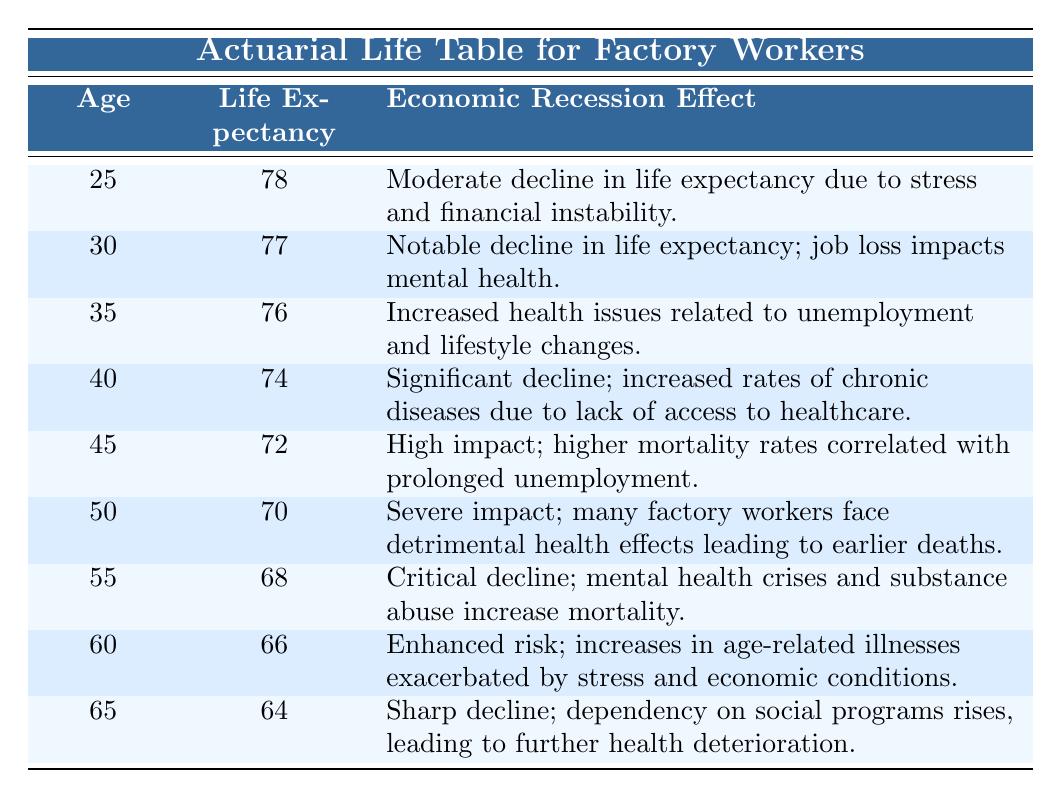What is the life expectancy of factory workers at age 50? The table indicates that the life expectancy of factory workers at age 50 is explicitly listed as 70 years.
Answer: 70 How does the economic recession affect life expectancy at age 40? The entry for age 40 states that there is a "significant decline; increased rates of chronic diseases due to lack of access to healthcare." This indicates that economic recession has a notable negative impact on health at this age.
Answer: Yes What is the difference in life expectancy between ages 35 and 60? The life expectancy for age 35 is 76 years, while for age 60, it is 66 years. Therefore, the difference in life expectancy is calculated as 76 - 66 = 10 years.
Answer: 10 Is there a critical decline in life expectancy for factory workers at age 55? The description for age 55 states “critical decline; mental health crises and substance abuse increase mortality,” which supports that there is indeed a critical decline at this age.
Answer: Yes What is the average life expectancy based on the provided age groups? To find the average, we first sum all the life expectancies: 78 + 77 + 76 + 74 + 72 + 70 + 68 + 66 + 64 = 585. Then, dividing by the number of age groups (9), we get 585 / 9 = 65.
Answer: 65 What is the overall trend in life expectancy from ages 25 to 65? Observing the table, life expectancy steadily decreases as age increases, specifically from 78 years at age 25 down to 64 years at age 65. This indicates a downward trend.
Answer: Yes How many age groups experience a life expectancy of below 70 years? Looking at the table, the ages with life expectancy below 70 are 50 (70), 55 (68), 60 (66), and 65 (64), totaling four age groups.
Answer: 4 What are the effects of economic recession on life expectancy between ages 30 and 45? At age 30, the effect is "notable decline in life expectancy; job loss impacts mental health," and at age 45, it states "high impact; higher mortality rates correlated with prolonged unemployment." The recession impacts are consistently negative, worsening from age 30 to 45.
Answer: Yes At which age group is the life expectancy the lowest, and what is the reason? The lowest life expectancy occurs at age 65, where it is 64 years due to "sharp decline; dependency on social programs rises, leading to further health deterioration." This indicates compounded social and health issues.
Answer: 65, 64 years 